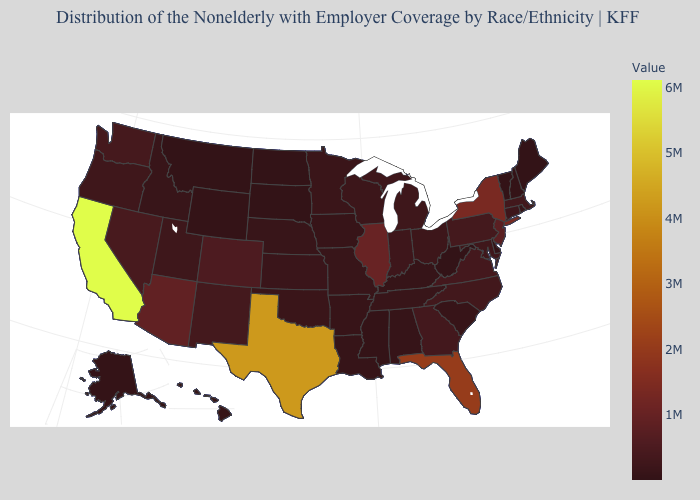Which states hav the highest value in the West?
Be succinct. California. Does New Hampshire have the lowest value in the Northeast?
Write a very short answer. No. 